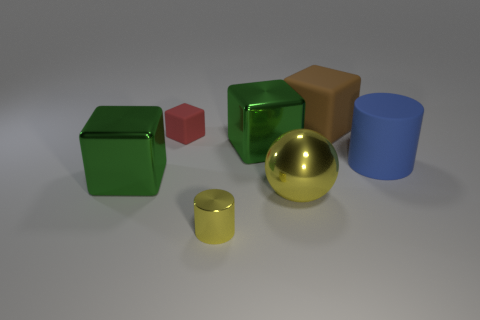Subtract all tiny rubber blocks. How many blocks are left? 3 Add 1 big purple metallic objects. How many objects exist? 8 Subtract all red cylinders. How many green blocks are left? 2 Subtract 2 blocks. How many blocks are left? 2 Subtract all red cubes. How many cubes are left? 3 Subtract all spheres. How many objects are left? 6 Subtract all cyan blocks. Subtract all gray cylinders. How many blocks are left? 4 Subtract all yellow shiny cylinders. Subtract all big matte cylinders. How many objects are left? 5 Add 7 green shiny things. How many green shiny things are left? 9 Add 7 big brown blocks. How many big brown blocks exist? 8 